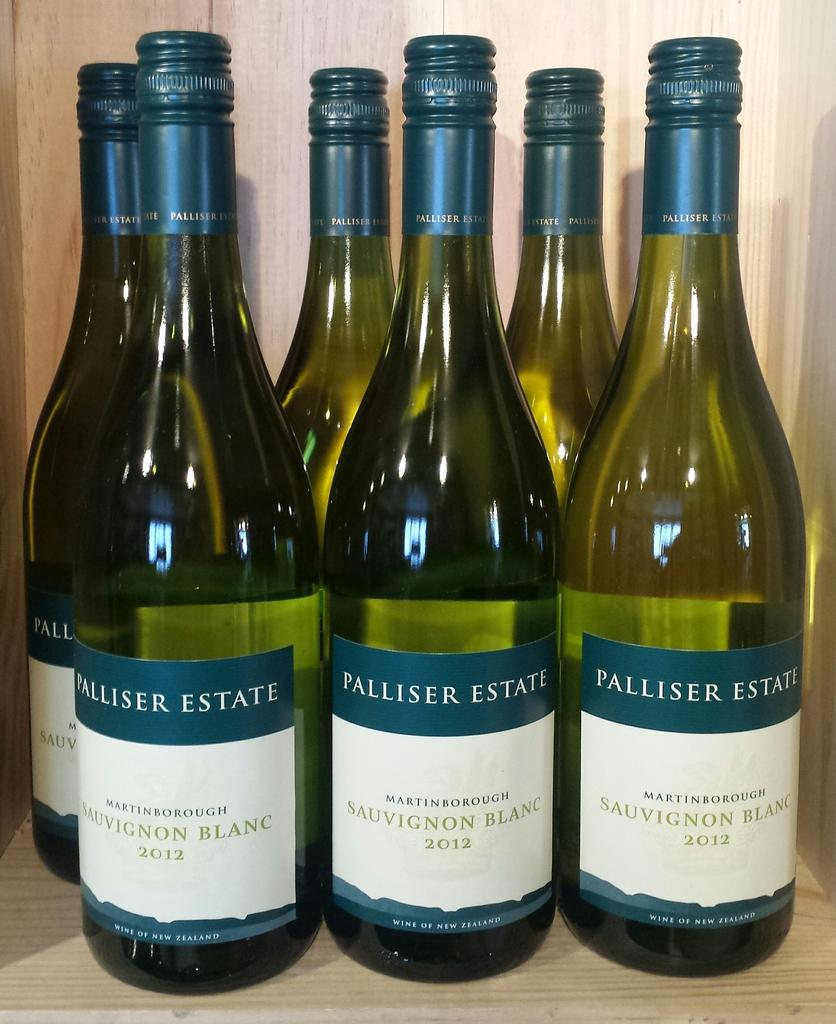<image>
Present a compact description of the photo's key features. Sauvignon Blank from the Palliser Estate sits on a wooden shelf. 